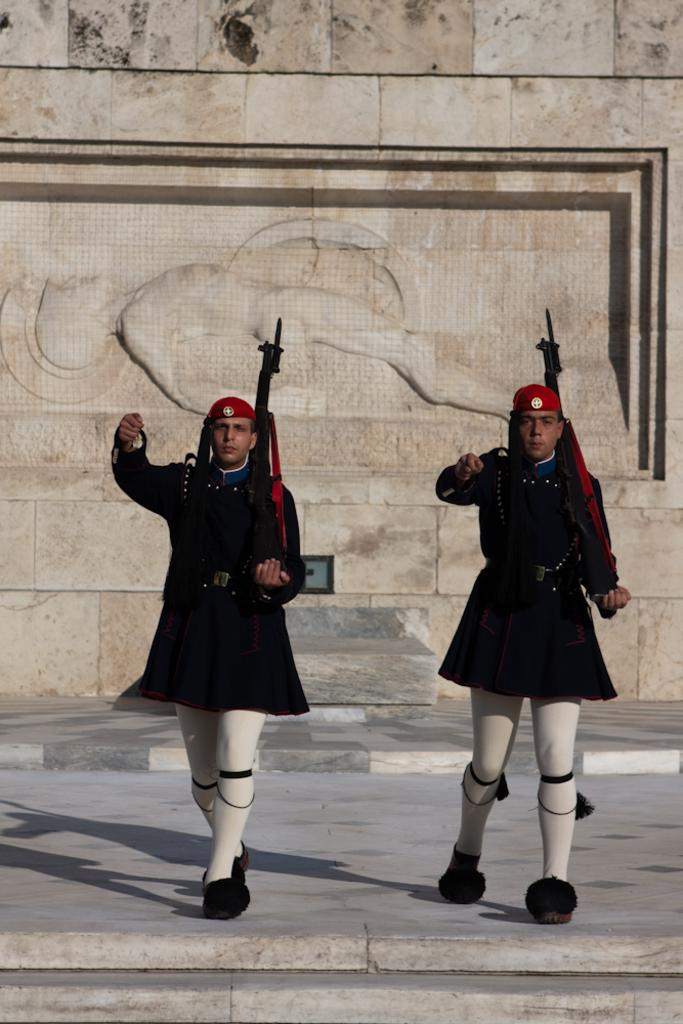What are the people in the image doing? The people in the image are walking. What are the people holding while walking? The people are holding guns. What can be seen in the background of the image? There appears to be a building in the background of the image. What is present on the wall in the image? There is carving on the wall in the image. How many babies are being fed vegetables by the people in the image? There are no babies or vegetables present in the image. 